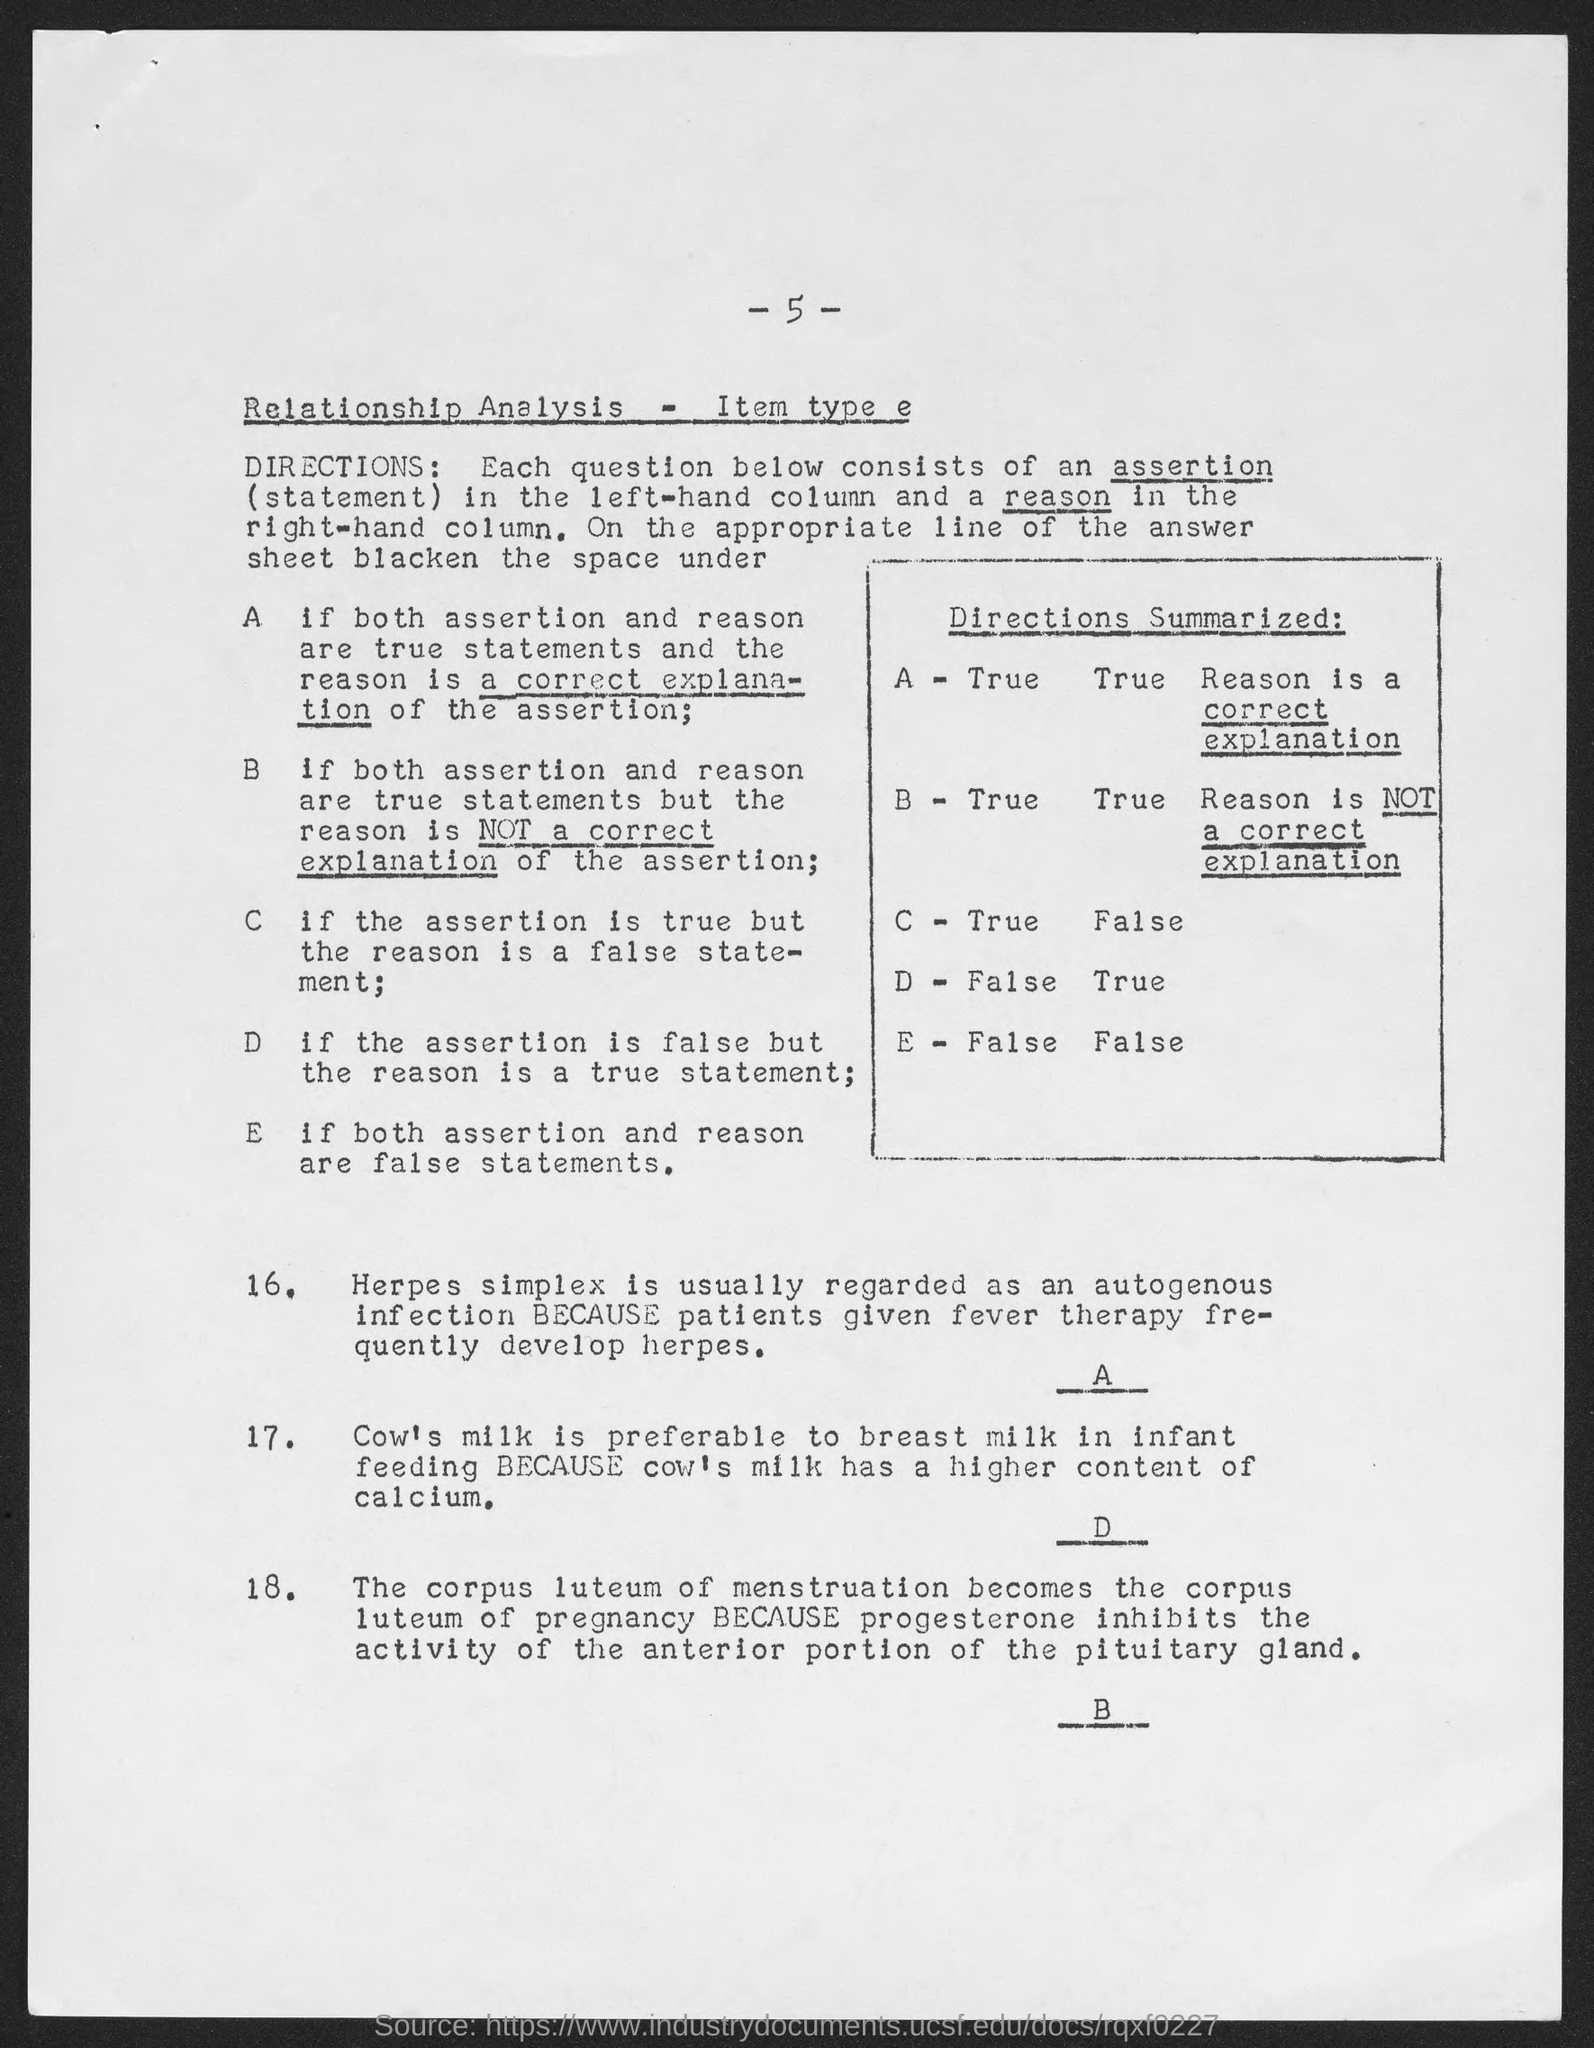Highlight a few significant elements in this photo. I am looking at a page that has a page number at the top of the page, and that number is 5. 